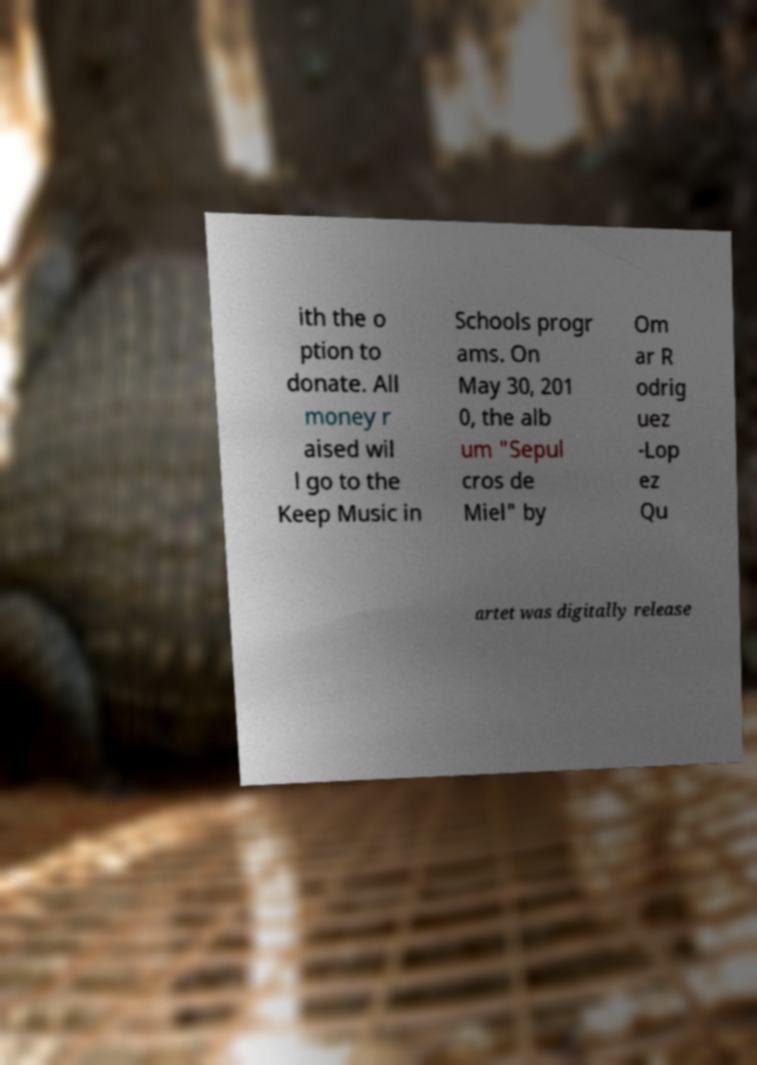Please identify and transcribe the text found in this image. ith the o ption to donate. All money r aised wil l go to the Keep Music in Schools progr ams. On May 30, 201 0, the alb um "Sepul cros de Miel" by Om ar R odrig uez -Lop ez Qu artet was digitally release 